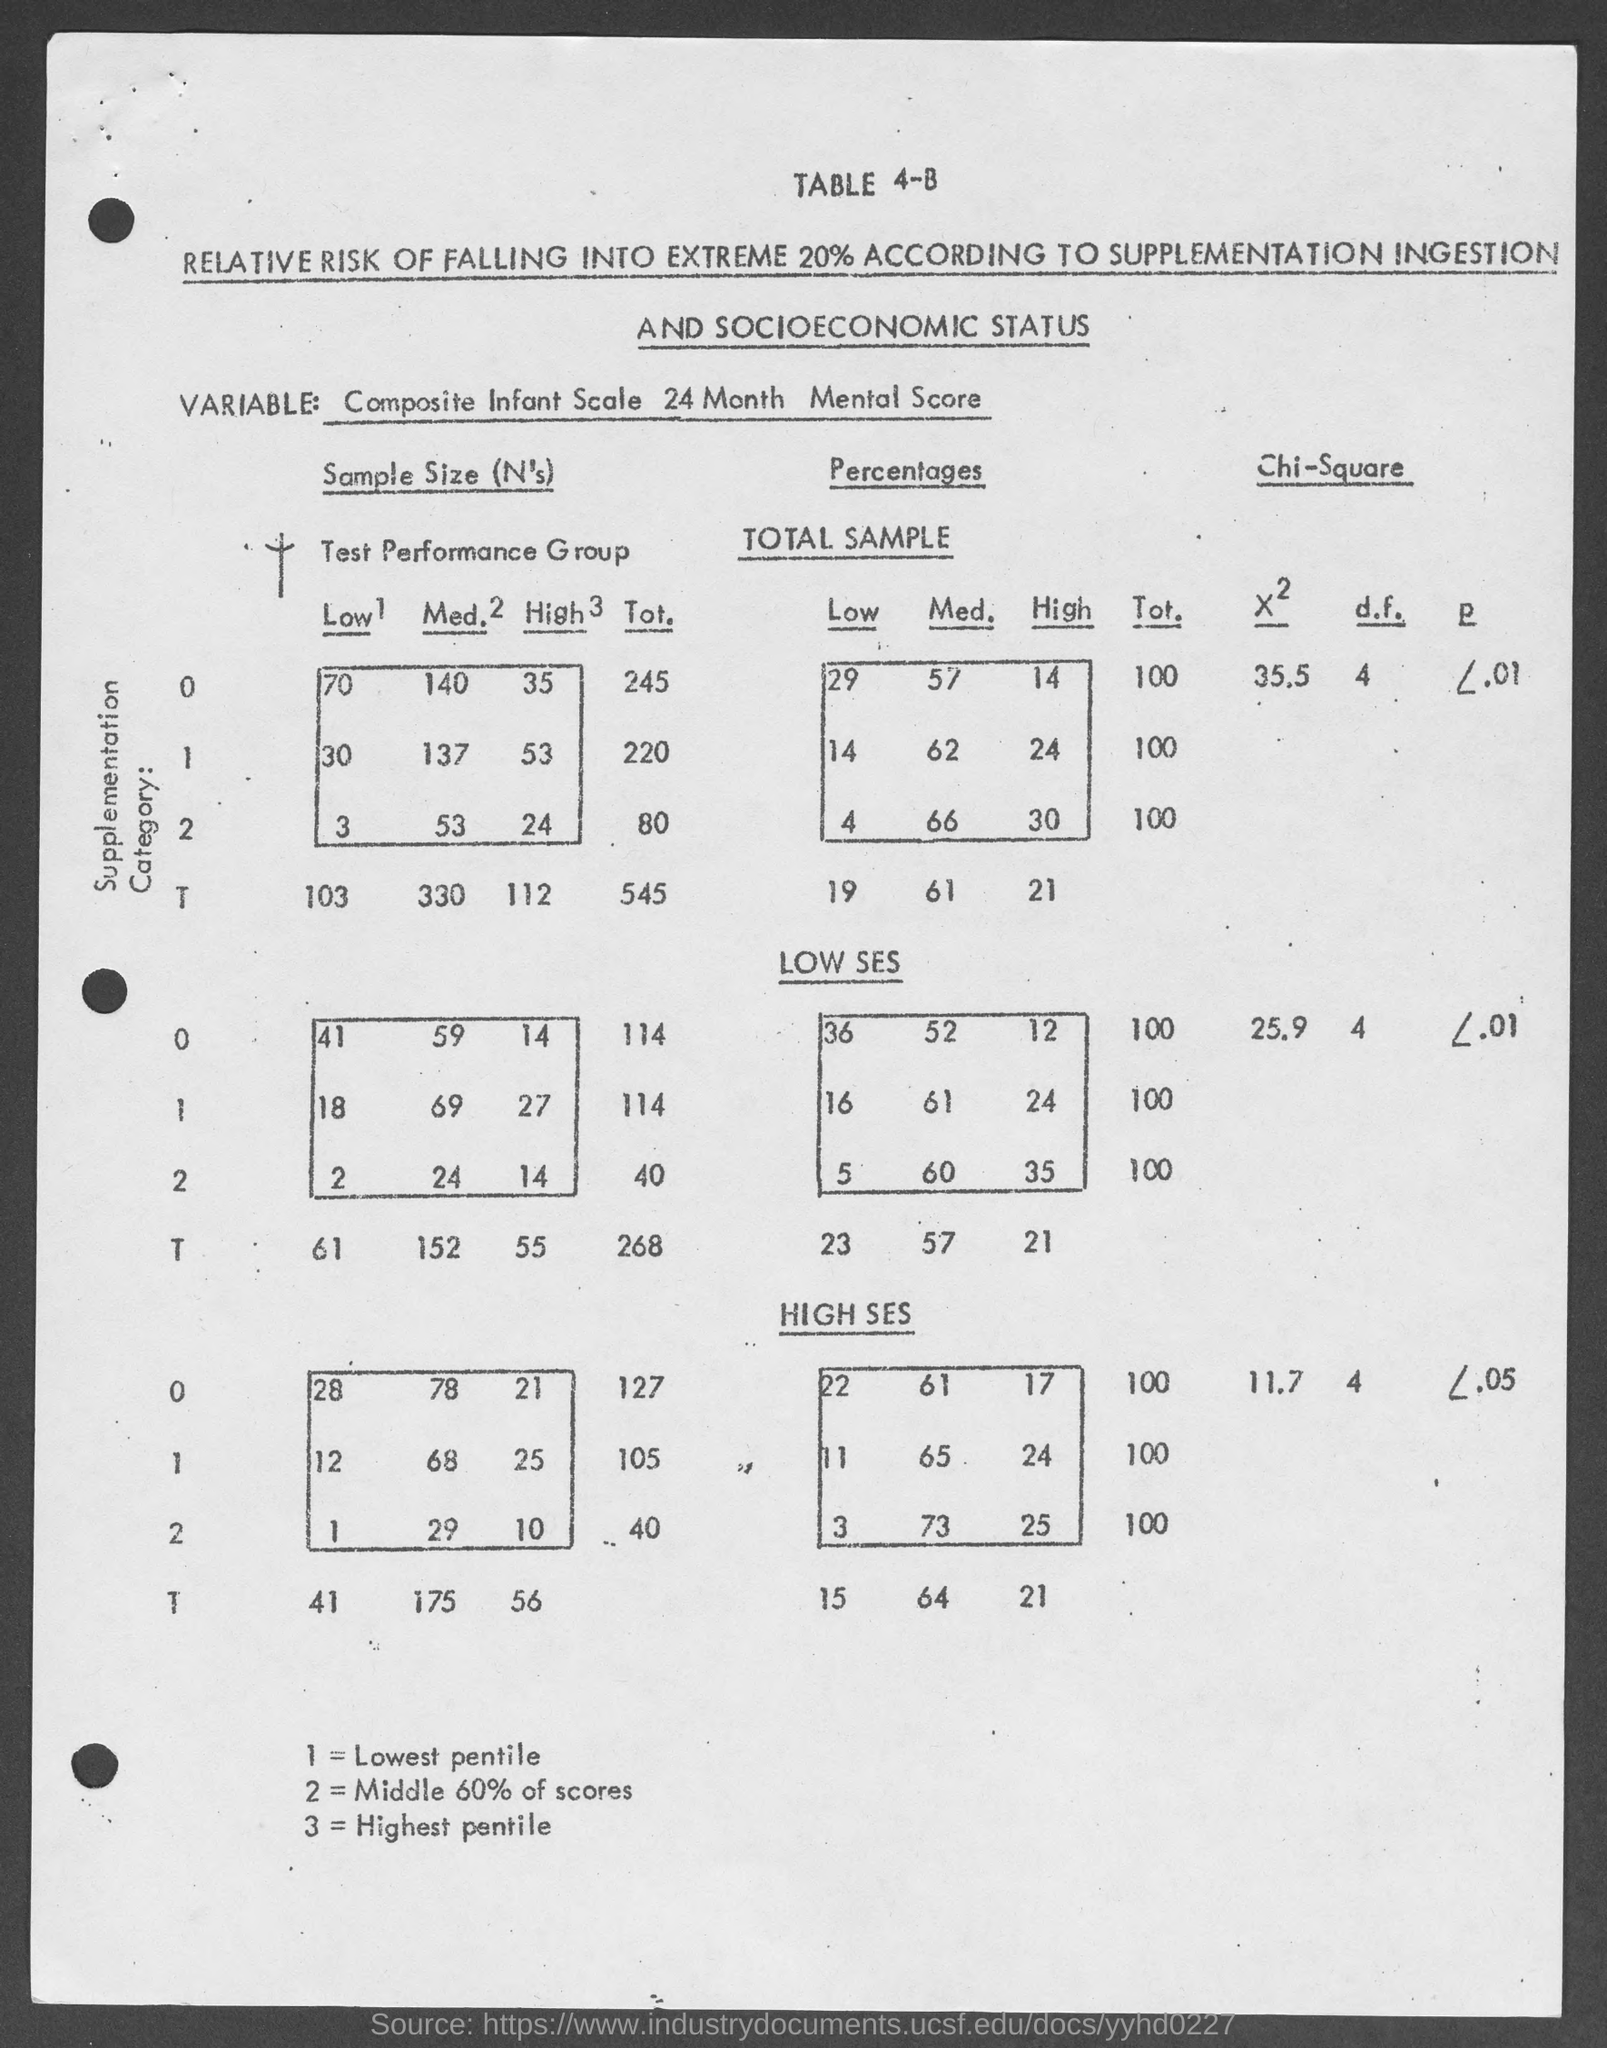Indicate a few pertinent items in this graphic. The middle 60% of scores is equal to 2. The highest pentile score for a 3-inch smartphone display is? What is the lowest pentile rating for a 1? I am trying to determine the answer to this question. 